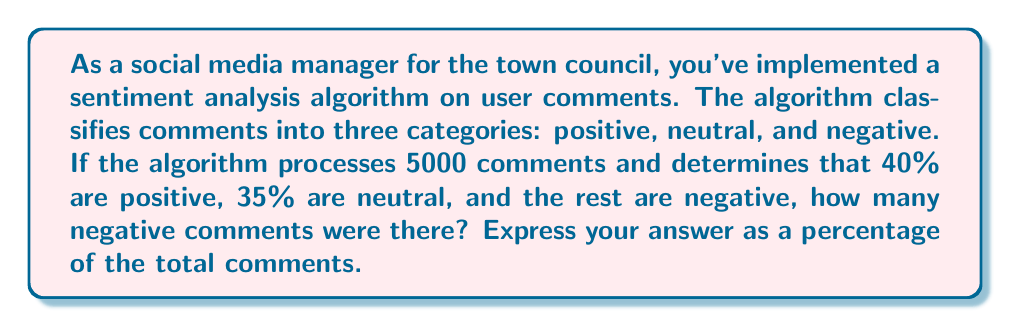Help me with this question. Let's approach this step-by-step:

1) First, let's define our variables:
   Let $p$ = percentage of positive comments
   Let $n$ = percentage of neutral comments
   Let $x$ = percentage of negative comments

2) We know that the percentages must add up to 100%:
   $$p + n + x = 100\%$$

3) We're given that:
   $p = 40\%$
   $n = 35\%$

4) Substituting these into our equation:
   $$40\% + 35\% + x = 100\%$$
   $$75\% + x = 100\%$$

5) Solving for $x$:
   $$x = 100\% - 75\% = 25\%$$

6) To double-check, let's ensure the percentages add up to 100%:
   $$40\% + 35\% + 25\% = 100\%$$

Therefore, 25% of the comments were negative.
Answer: 25% 